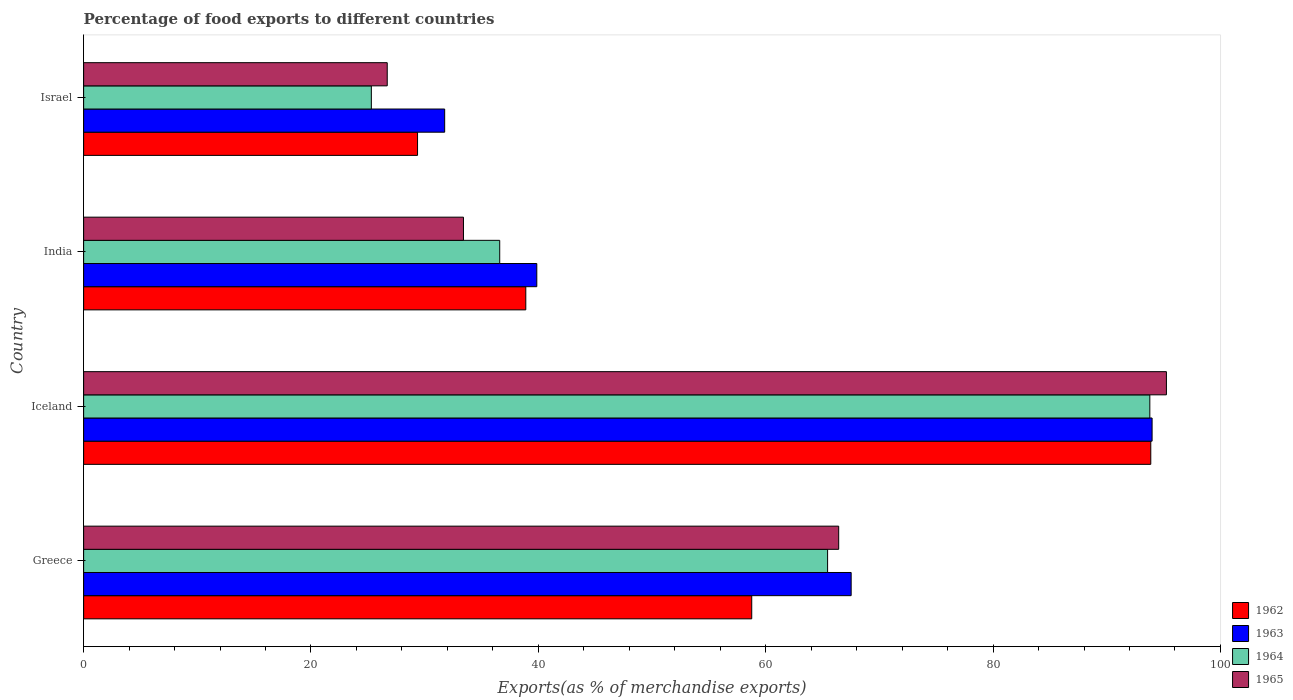How many different coloured bars are there?
Offer a very short reply. 4. How many groups of bars are there?
Ensure brevity in your answer.  4. Are the number of bars on each tick of the Y-axis equal?
Offer a terse response. Yes. How many bars are there on the 2nd tick from the top?
Keep it short and to the point. 4. How many bars are there on the 4th tick from the bottom?
Ensure brevity in your answer.  4. What is the percentage of exports to different countries in 1964 in Greece?
Offer a terse response. 65.45. Across all countries, what is the maximum percentage of exports to different countries in 1963?
Provide a succinct answer. 93.99. Across all countries, what is the minimum percentage of exports to different countries in 1962?
Your response must be concise. 29.37. In which country was the percentage of exports to different countries in 1965 minimum?
Your response must be concise. Israel. What is the total percentage of exports to different countries in 1963 in the graph?
Ensure brevity in your answer.  233.13. What is the difference between the percentage of exports to different countries in 1965 in Greece and that in Israel?
Offer a very short reply. 39.71. What is the difference between the percentage of exports to different countries in 1964 in Greece and the percentage of exports to different countries in 1965 in Israel?
Give a very brief answer. 38.74. What is the average percentage of exports to different countries in 1965 per country?
Your answer should be very brief. 55.45. What is the difference between the percentage of exports to different countries in 1962 and percentage of exports to different countries in 1964 in Greece?
Provide a short and direct response. -6.67. What is the ratio of the percentage of exports to different countries in 1962 in Iceland to that in Israel?
Offer a terse response. 3.2. Is the percentage of exports to different countries in 1964 in Greece less than that in Iceland?
Ensure brevity in your answer.  Yes. What is the difference between the highest and the second highest percentage of exports to different countries in 1964?
Make the answer very short. 28.35. What is the difference between the highest and the lowest percentage of exports to different countries in 1965?
Your response must be concise. 68.54. In how many countries, is the percentage of exports to different countries in 1963 greater than the average percentage of exports to different countries in 1963 taken over all countries?
Offer a very short reply. 2. What does the 3rd bar from the top in Iceland represents?
Keep it short and to the point. 1963. What does the 4th bar from the bottom in Greece represents?
Provide a succinct answer. 1965. Is it the case that in every country, the sum of the percentage of exports to different countries in 1964 and percentage of exports to different countries in 1965 is greater than the percentage of exports to different countries in 1962?
Your response must be concise. Yes. How many bars are there?
Offer a terse response. 16. How many countries are there in the graph?
Make the answer very short. 4. What is the difference between two consecutive major ticks on the X-axis?
Provide a short and direct response. 20. Are the values on the major ticks of X-axis written in scientific E-notation?
Offer a very short reply. No. Where does the legend appear in the graph?
Give a very brief answer. Bottom right. What is the title of the graph?
Your answer should be very brief. Percentage of food exports to different countries. Does "1992" appear as one of the legend labels in the graph?
Keep it short and to the point. No. What is the label or title of the X-axis?
Your answer should be very brief. Exports(as % of merchandise exports). What is the label or title of the Y-axis?
Provide a short and direct response. Country. What is the Exports(as % of merchandise exports) of 1962 in Greece?
Your answer should be very brief. 58.77. What is the Exports(as % of merchandise exports) in 1963 in Greece?
Make the answer very short. 67.52. What is the Exports(as % of merchandise exports) in 1964 in Greece?
Make the answer very short. 65.45. What is the Exports(as % of merchandise exports) in 1965 in Greece?
Your answer should be very brief. 66.42. What is the Exports(as % of merchandise exports) of 1962 in Iceland?
Offer a terse response. 93.87. What is the Exports(as % of merchandise exports) of 1963 in Iceland?
Make the answer very short. 93.99. What is the Exports(as % of merchandise exports) of 1964 in Iceland?
Provide a short and direct response. 93.79. What is the Exports(as % of merchandise exports) of 1965 in Iceland?
Offer a very short reply. 95.25. What is the Exports(as % of merchandise exports) of 1962 in India?
Provide a succinct answer. 38.9. What is the Exports(as % of merchandise exports) in 1963 in India?
Provide a succinct answer. 39.86. What is the Exports(as % of merchandise exports) of 1964 in India?
Offer a terse response. 36.6. What is the Exports(as % of merchandise exports) in 1965 in India?
Ensure brevity in your answer.  33.41. What is the Exports(as % of merchandise exports) in 1962 in Israel?
Provide a short and direct response. 29.37. What is the Exports(as % of merchandise exports) of 1963 in Israel?
Offer a terse response. 31.76. What is the Exports(as % of merchandise exports) in 1964 in Israel?
Keep it short and to the point. 25.31. What is the Exports(as % of merchandise exports) of 1965 in Israel?
Give a very brief answer. 26.71. Across all countries, what is the maximum Exports(as % of merchandise exports) in 1962?
Keep it short and to the point. 93.87. Across all countries, what is the maximum Exports(as % of merchandise exports) of 1963?
Offer a terse response. 93.99. Across all countries, what is the maximum Exports(as % of merchandise exports) in 1964?
Ensure brevity in your answer.  93.79. Across all countries, what is the maximum Exports(as % of merchandise exports) of 1965?
Your answer should be very brief. 95.25. Across all countries, what is the minimum Exports(as % of merchandise exports) of 1962?
Provide a succinct answer. 29.37. Across all countries, what is the minimum Exports(as % of merchandise exports) of 1963?
Your answer should be very brief. 31.76. Across all countries, what is the minimum Exports(as % of merchandise exports) of 1964?
Your response must be concise. 25.31. Across all countries, what is the minimum Exports(as % of merchandise exports) in 1965?
Make the answer very short. 26.71. What is the total Exports(as % of merchandise exports) in 1962 in the graph?
Make the answer very short. 220.92. What is the total Exports(as % of merchandise exports) in 1963 in the graph?
Provide a succinct answer. 233.13. What is the total Exports(as % of merchandise exports) in 1964 in the graph?
Provide a succinct answer. 221.15. What is the total Exports(as % of merchandise exports) of 1965 in the graph?
Provide a short and direct response. 221.79. What is the difference between the Exports(as % of merchandise exports) of 1962 in Greece and that in Iceland?
Offer a terse response. -35.1. What is the difference between the Exports(as % of merchandise exports) in 1963 in Greece and that in Iceland?
Offer a very short reply. -26.47. What is the difference between the Exports(as % of merchandise exports) of 1964 in Greece and that in Iceland?
Ensure brevity in your answer.  -28.35. What is the difference between the Exports(as % of merchandise exports) in 1965 in Greece and that in Iceland?
Make the answer very short. -28.83. What is the difference between the Exports(as % of merchandise exports) of 1962 in Greece and that in India?
Your response must be concise. 19.87. What is the difference between the Exports(as % of merchandise exports) of 1963 in Greece and that in India?
Your response must be concise. 27.65. What is the difference between the Exports(as % of merchandise exports) of 1964 in Greece and that in India?
Your response must be concise. 28.84. What is the difference between the Exports(as % of merchandise exports) of 1965 in Greece and that in India?
Provide a succinct answer. 33.01. What is the difference between the Exports(as % of merchandise exports) of 1962 in Greece and that in Israel?
Offer a terse response. 29.4. What is the difference between the Exports(as % of merchandise exports) in 1963 in Greece and that in Israel?
Ensure brevity in your answer.  35.76. What is the difference between the Exports(as % of merchandise exports) in 1964 in Greece and that in Israel?
Give a very brief answer. 40.14. What is the difference between the Exports(as % of merchandise exports) in 1965 in Greece and that in Israel?
Give a very brief answer. 39.71. What is the difference between the Exports(as % of merchandise exports) of 1962 in Iceland and that in India?
Provide a succinct answer. 54.98. What is the difference between the Exports(as % of merchandise exports) in 1963 in Iceland and that in India?
Your answer should be very brief. 54.13. What is the difference between the Exports(as % of merchandise exports) in 1964 in Iceland and that in India?
Offer a very short reply. 57.19. What is the difference between the Exports(as % of merchandise exports) in 1965 in Iceland and that in India?
Keep it short and to the point. 61.84. What is the difference between the Exports(as % of merchandise exports) in 1962 in Iceland and that in Israel?
Keep it short and to the point. 64.5. What is the difference between the Exports(as % of merchandise exports) of 1963 in Iceland and that in Israel?
Provide a succinct answer. 62.23. What is the difference between the Exports(as % of merchandise exports) of 1964 in Iceland and that in Israel?
Your answer should be very brief. 68.48. What is the difference between the Exports(as % of merchandise exports) in 1965 in Iceland and that in Israel?
Keep it short and to the point. 68.54. What is the difference between the Exports(as % of merchandise exports) in 1962 in India and that in Israel?
Offer a terse response. 9.52. What is the difference between the Exports(as % of merchandise exports) in 1963 in India and that in Israel?
Your response must be concise. 8.1. What is the difference between the Exports(as % of merchandise exports) in 1964 in India and that in Israel?
Provide a short and direct response. 11.29. What is the difference between the Exports(as % of merchandise exports) of 1965 in India and that in Israel?
Keep it short and to the point. 6.71. What is the difference between the Exports(as % of merchandise exports) of 1962 in Greece and the Exports(as % of merchandise exports) of 1963 in Iceland?
Offer a terse response. -35.22. What is the difference between the Exports(as % of merchandise exports) of 1962 in Greece and the Exports(as % of merchandise exports) of 1964 in Iceland?
Keep it short and to the point. -35.02. What is the difference between the Exports(as % of merchandise exports) of 1962 in Greece and the Exports(as % of merchandise exports) of 1965 in Iceland?
Provide a short and direct response. -36.48. What is the difference between the Exports(as % of merchandise exports) in 1963 in Greece and the Exports(as % of merchandise exports) in 1964 in Iceland?
Your answer should be very brief. -26.27. What is the difference between the Exports(as % of merchandise exports) of 1963 in Greece and the Exports(as % of merchandise exports) of 1965 in Iceland?
Your answer should be compact. -27.73. What is the difference between the Exports(as % of merchandise exports) of 1964 in Greece and the Exports(as % of merchandise exports) of 1965 in Iceland?
Keep it short and to the point. -29.8. What is the difference between the Exports(as % of merchandise exports) in 1962 in Greece and the Exports(as % of merchandise exports) in 1963 in India?
Keep it short and to the point. 18.91. What is the difference between the Exports(as % of merchandise exports) in 1962 in Greece and the Exports(as % of merchandise exports) in 1964 in India?
Your response must be concise. 22.17. What is the difference between the Exports(as % of merchandise exports) in 1962 in Greece and the Exports(as % of merchandise exports) in 1965 in India?
Ensure brevity in your answer.  25.36. What is the difference between the Exports(as % of merchandise exports) of 1963 in Greece and the Exports(as % of merchandise exports) of 1964 in India?
Provide a short and direct response. 30.92. What is the difference between the Exports(as % of merchandise exports) in 1963 in Greece and the Exports(as % of merchandise exports) in 1965 in India?
Offer a very short reply. 34.1. What is the difference between the Exports(as % of merchandise exports) of 1964 in Greece and the Exports(as % of merchandise exports) of 1965 in India?
Your response must be concise. 32.03. What is the difference between the Exports(as % of merchandise exports) in 1962 in Greece and the Exports(as % of merchandise exports) in 1963 in Israel?
Your answer should be compact. 27.01. What is the difference between the Exports(as % of merchandise exports) of 1962 in Greece and the Exports(as % of merchandise exports) of 1964 in Israel?
Offer a terse response. 33.46. What is the difference between the Exports(as % of merchandise exports) of 1962 in Greece and the Exports(as % of merchandise exports) of 1965 in Israel?
Provide a short and direct response. 32.06. What is the difference between the Exports(as % of merchandise exports) in 1963 in Greece and the Exports(as % of merchandise exports) in 1964 in Israel?
Provide a succinct answer. 42.21. What is the difference between the Exports(as % of merchandise exports) of 1963 in Greece and the Exports(as % of merchandise exports) of 1965 in Israel?
Offer a very short reply. 40.81. What is the difference between the Exports(as % of merchandise exports) in 1964 in Greece and the Exports(as % of merchandise exports) in 1965 in Israel?
Provide a short and direct response. 38.74. What is the difference between the Exports(as % of merchandise exports) in 1962 in Iceland and the Exports(as % of merchandise exports) in 1963 in India?
Ensure brevity in your answer.  54.01. What is the difference between the Exports(as % of merchandise exports) of 1962 in Iceland and the Exports(as % of merchandise exports) of 1964 in India?
Your answer should be compact. 57.27. What is the difference between the Exports(as % of merchandise exports) in 1962 in Iceland and the Exports(as % of merchandise exports) in 1965 in India?
Your answer should be compact. 60.46. What is the difference between the Exports(as % of merchandise exports) of 1963 in Iceland and the Exports(as % of merchandise exports) of 1964 in India?
Keep it short and to the point. 57.39. What is the difference between the Exports(as % of merchandise exports) of 1963 in Iceland and the Exports(as % of merchandise exports) of 1965 in India?
Provide a succinct answer. 60.58. What is the difference between the Exports(as % of merchandise exports) in 1964 in Iceland and the Exports(as % of merchandise exports) in 1965 in India?
Offer a terse response. 60.38. What is the difference between the Exports(as % of merchandise exports) of 1962 in Iceland and the Exports(as % of merchandise exports) of 1963 in Israel?
Ensure brevity in your answer.  62.11. What is the difference between the Exports(as % of merchandise exports) of 1962 in Iceland and the Exports(as % of merchandise exports) of 1964 in Israel?
Your response must be concise. 68.57. What is the difference between the Exports(as % of merchandise exports) of 1962 in Iceland and the Exports(as % of merchandise exports) of 1965 in Israel?
Provide a short and direct response. 67.17. What is the difference between the Exports(as % of merchandise exports) in 1963 in Iceland and the Exports(as % of merchandise exports) in 1964 in Israel?
Your response must be concise. 68.68. What is the difference between the Exports(as % of merchandise exports) of 1963 in Iceland and the Exports(as % of merchandise exports) of 1965 in Israel?
Your answer should be very brief. 67.28. What is the difference between the Exports(as % of merchandise exports) in 1964 in Iceland and the Exports(as % of merchandise exports) in 1965 in Israel?
Your answer should be compact. 67.08. What is the difference between the Exports(as % of merchandise exports) of 1962 in India and the Exports(as % of merchandise exports) of 1963 in Israel?
Keep it short and to the point. 7.14. What is the difference between the Exports(as % of merchandise exports) in 1962 in India and the Exports(as % of merchandise exports) in 1964 in Israel?
Provide a succinct answer. 13.59. What is the difference between the Exports(as % of merchandise exports) in 1962 in India and the Exports(as % of merchandise exports) in 1965 in Israel?
Give a very brief answer. 12.19. What is the difference between the Exports(as % of merchandise exports) of 1963 in India and the Exports(as % of merchandise exports) of 1964 in Israel?
Make the answer very short. 14.56. What is the difference between the Exports(as % of merchandise exports) of 1963 in India and the Exports(as % of merchandise exports) of 1965 in Israel?
Your answer should be very brief. 13.16. What is the difference between the Exports(as % of merchandise exports) in 1964 in India and the Exports(as % of merchandise exports) in 1965 in Israel?
Your answer should be very brief. 9.89. What is the average Exports(as % of merchandise exports) in 1962 per country?
Provide a succinct answer. 55.23. What is the average Exports(as % of merchandise exports) in 1963 per country?
Offer a terse response. 58.28. What is the average Exports(as % of merchandise exports) in 1964 per country?
Keep it short and to the point. 55.29. What is the average Exports(as % of merchandise exports) in 1965 per country?
Ensure brevity in your answer.  55.45. What is the difference between the Exports(as % of merchandise exports) in 1962 and Exports(as % of merchandise exports) in 1963 in Greece?
Provide a short and direct response. -8.75. What is the difference between the Exports(as % of merchandise exports) of 1962 and Exports(as % of merchandise exports) of 1964 in Greece?
Provide a short and direct response. -6.67. What is the difference between the Exports(as % of merchandise exports) of 1962 and Exports(as % of merchandise exports) of 1965 in Greece?
Give a very brief answer. -7.65. What is the difference between the Exports(as % of merchandise exports) of 1963 and Exports(as % of merchandise exports) of 1964 in Greece?
Give a very brief answer. 2.07. What is the difference between the Exports(as % of merchandise exports) in 1963 and Exports(as % of merchandise exports) in 1965 in Greece?
Provide a succinct answer. 1.1. What is the difference between the Exports(as % of merchandise exports) of 1964 and Exports(as % of merchandise exports) of 1965 in Greece?
Offer a very short reply. -0.98. What is the difference between the Exports(as % of merchandise exports) in 1962 and Exports(as % of merchandise exports) in 1963 in Iceland?
Your answer should be very brief. -0.12. What is the difference between the Exports(as % of merchandise exports) of 1962 and Exports(as % of merchandise exports) of 1964 in Iceland?
Your answer should be compact. 0.08. What is the difference between the Exports(as % of merchandise exports) of 1962 and Exports(as % of merchandise exports) of 1965 in Iceland?
Your response must be concise. -1.38. What is the difference between the Exports(as % of merchandise exports) of 1963 and Exports(as % of merchandise exports) of 1965 in Iceland?
Ensure brevity in your answer.  -1.26. What is the difference between the Exports(as % of merchandise exports) in 1964 and Exports(as % of merchandise exports) in 1965 in Iceland?
Your answer should be very brief. -1.46. What is the difference between the Exports(as % of merchandise exports) of 1962 and Exports(as % of merchandise exports) of 1963 in India?
Offer a terse response. -0.97. What is the difference between the Exports(as % of merchandise exports) in 1962 and Exports(as % of merchandise exports) in 1964 in India?
Your response must be concise. 2.29. What is the difference between the Exports(as % of merchandise exports) in 1962 and Exports(as % of merchandise exports) in 1965 in India?
Keep it short and to the point. 5.48. What is the difference between the Exports(as % of merchandise exports) in 1963 and Exports(as % of merchandise exports) in 1964 in India?
Give a very brief answer. 3.26. What is the difference between the Exports(as % of merchandise exports) of 1963 and Exports(as % of merchandise exports) of 1965 in India?
Offer a terse response. 6.45. What is the difference between the Exports(as % of merchandise exports) of 1964 and Exports(as % of merchandise exports) of 1965 in India?
Keep it short and to the point. 3.19. What is the difference between the Exports(as % of merchandise exports) of 1962 and Exports(as % of merchandise exports) of 1963 in Israel?
Offer a terse response. -2.39. What is the difference between the Exports(as % of merchandise exports) of 1962 and Exports(as % of merchandise exports) of 1964 in Israel?
Make the answer very short. 4.07. What is the difference between the Exports(as % of merchandise exports) in 1962 and Exports(as % of merchandise exports) in 1965 in Israel?
Give a very brief answer. 2.67. What is the difference between the Exports(as % of merchandise exports) in 1963 and Exports(as % of merchandise exports) in 1964 in Israel?
Offer a very short reply. 6.45. What is the difference between the Exports(as % of merchandise exports) in 1963 and Exports(as % of merchandise exports) in 1965 in Israel?
Provide a succinct answer. 5.05. What is the difference between the Exports(as % of merchandise exports) in 1964 and Exports(as % of merchandise exports) in 1965 in Israel?
Keep it short and to the point. -1.4. What is the ratio of the Exports(as % of merchandise exports) of 1962 in Greece to that in Iceland?
Provide a succinct answer. 0.63. What is the ratio of the Exports(as % of merchandise exports) in 1963 in Greece to that in Iceland?
Provide a short and direct response. 0.72. What is the ratio of the Exports(as % of merchandise exports) in 1964 in Greece to that in Iceland?
Ensure brevity in your answer.  0.7. What is the ratio of the Exports(as % of merchandise exports) of 1965 in Greece to that in Iceland?
Give a very brief answer. 0.7. What is the ratio of the Exports(as % of merchandise exports) in 1962 in Greece to that in India?
Ensure brevity in your answer.  1.51. What is the ratio of the Exports(as % of merchandise exports) in 1963 in Greece to that in India?
Your response must be concise. 1.69. What is the ratio of the Exports(as % of merchandise exports) in 1964 in Greece to that in India?
Keep it short and to the point. 1.79. What is the ratio of the Exports(as % of merchandise exports) in 1965 in Greece to that in India?
Your response must be concise. 1.99. What is the ratio of the Exports(as % of merchandise exports) in 1962 in Greece to that in Israel?
Keep it short and to the point. 2. What is the ratio of the Exports(as % of merchandise exports) of 1963 in Greece to that in Israel?
Your response must be concise. 2.13. What is the ratio of the Exports(as % of merchandise exports) in 1964 in Greece to that in Israel?
Your answer should be compact. 2.59. What is the ratio of the Exports(as % of merchandise exports) in 1965 in Greece to that in Israel?
Ensure brevity in your answer.  2.49. What is the ratio of the Exports(as % of merchandise exports) in 1962 in Iceland to that in India?
Your answer should be compact. 2.41. What is the ratio of the Exports(as % of merchandise exports) of 1963 in Iceland to that in India?
Offer a very short reply. 2.36. What is the ratio of the Exports(as % of merchandise exports) of 1964 in Iceland to that in India?
Offer a very short reply. 2.56. What is the ratio of the Exports(as % of merchandise exports) of 1965 in Iceland to that in India?
Make the answer very short. 2.85. What is the ratio of the Exports(as % of merchandise exports) in 1962 in Iceland to that in Israel?
Give a very brief answer. 3.2. What is the ratio of the Exports(as % of merchandise exports) in 1963 in Iceland to that in Israel?
Offer a terse response. 2.96. What is the ratio of the Exports(as % of merchandise exports) in 1964 in Iceland to that in Israel?
Keep it short and to the point. 3.71. What is the ratio of the Exports(as % of merchandise exports) of 1965 in Iceland to that in Israel?
Give a very brief answer. 3.57. What is the ratio of the Exports(as % of merchandise exports) of 1962 in India to that in Israel?
Ensure brevity in your answer.  1.32. What is the ratio of the Exports(as % of merchandise exports) in 1963 in India to that in Israel?
Provide a short and direct response. 1.26. What is the ratio of the Exports(as % of merchandise exports) in 1964 in India to that in Israel?
Ensure brevity in your answer.  1.45. What is the ratio of the Exports(as % of merchandise exports) in 1965 in India to that in Israel?
Provide a succinct answer. 1.25. What is the difference between the highest and the second highest Exports(as % of merchandise exports) in 1962?
Provide a succinct answer. 35.1. What is the difference between the highest and the second highest Exports(as % of merchandise exports) in 1963?
Offer a terse response. 26.47. What is the difference between the highest and the second highest Exports(as % of merchandise exports) of 1964?
Your answer should be very brief. 28.35. What is the difference between the highest and the second highest Exports(as % of merchandise exports) in 1965?
Your response must be concise. 28.83. What is the difference between the highest and the lowest Exports(as % of merchandise exports) of 1962?
Provide a succinct answer. 64.5. What is the difference between the highest and the lowest Exports(as % of merchandise exports) of 1963?
Give a very brief answer. 62.23. What is the difference between the highest and the lowest Exports(as % of merchandise exports) of 1964?
Your answer should be very brief. 68.48. What is the difference between the highest and the lowest Exports(as % of merchandise exports) in 1965?
Provide a short and direct response. 68.54. 